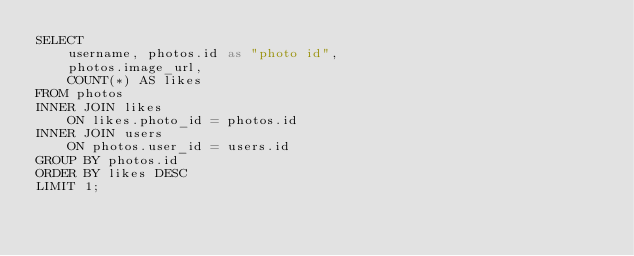<code> <loc_0><loc_0><loc_500><loc_500><_SQL_>SELECT 
    username, photos.id as "photo id", 
    photos.image_url,
    COUNT(*) AS likes
FROM photos
INNER JOIN likes
    ON likes.photo_id = photos.id
INNER JOIN users
    ON photos.user_id = users.id
GROUP BY photos.id
ORDER BY likes DESC
LIMIT 1;
</code> 